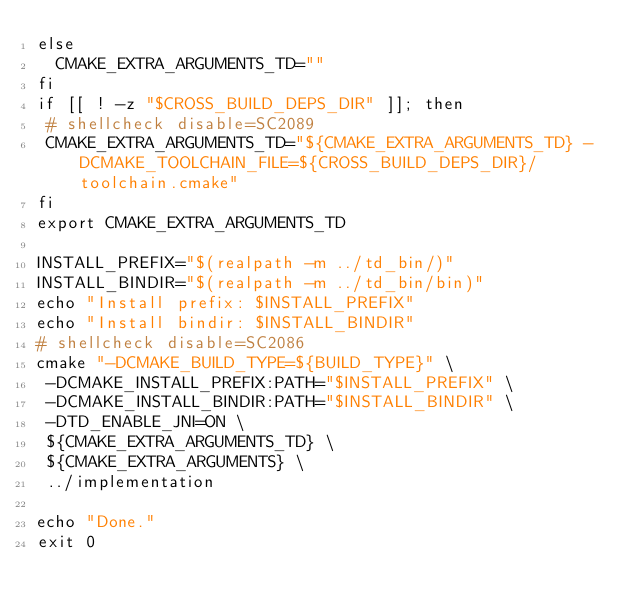Convert code to text. <code><loc_0><loc_0><loc_500><loc_500><_Bash_>else
  CMAKE_EXTRA_ARGUMENTS_TD=""
fi
if [[ ! -z "$CROSS_BUILD_DEPS_DIR" ]]; then
 # shellcheck disable=SC2089
 CMAKE_EXTRA_ARGUMENTS_TD="${CMAKE_EXTRA_ARGUMENTS_TD} -DCMAKE_TOOLCHAIN_FILE=${CROSS_BUILD_DEPS_DIR}/toolchain.cmake"
fi
export CMAKE_EXTRA_ARGUMENTS_TD

INSTALL_PREFIX="$(realpath -m ../td_bin/)"
INSTALL_BINDIR="$(realpath -m ../td_bin/bin)"
echo "Install prefix: $INSTALL_PREFIX"
echo "Install bindir: $INSTALL_BINDIR"
# shellcheck disable=SC2086
cmake "-DCMAKE_BUILD_TYPE=${BUILD_TYPE}" \
 -DCMAKE_INSTALL_PREFIX:PATH="$INSTALL_PREFIX" \
 -DCMAKE_INSTALL_BINDIR:PATH="$INSTALL_BINDIR" \
 -DTD_ENABLE_JNI=ON \
 ${CMAKE_EXTRA_ARGUMENTS_TD} \
 ${CMAKE_EXTRA_ARGUMENTS} \
 ../implementation

echo "Done."
exit 0
</code> 